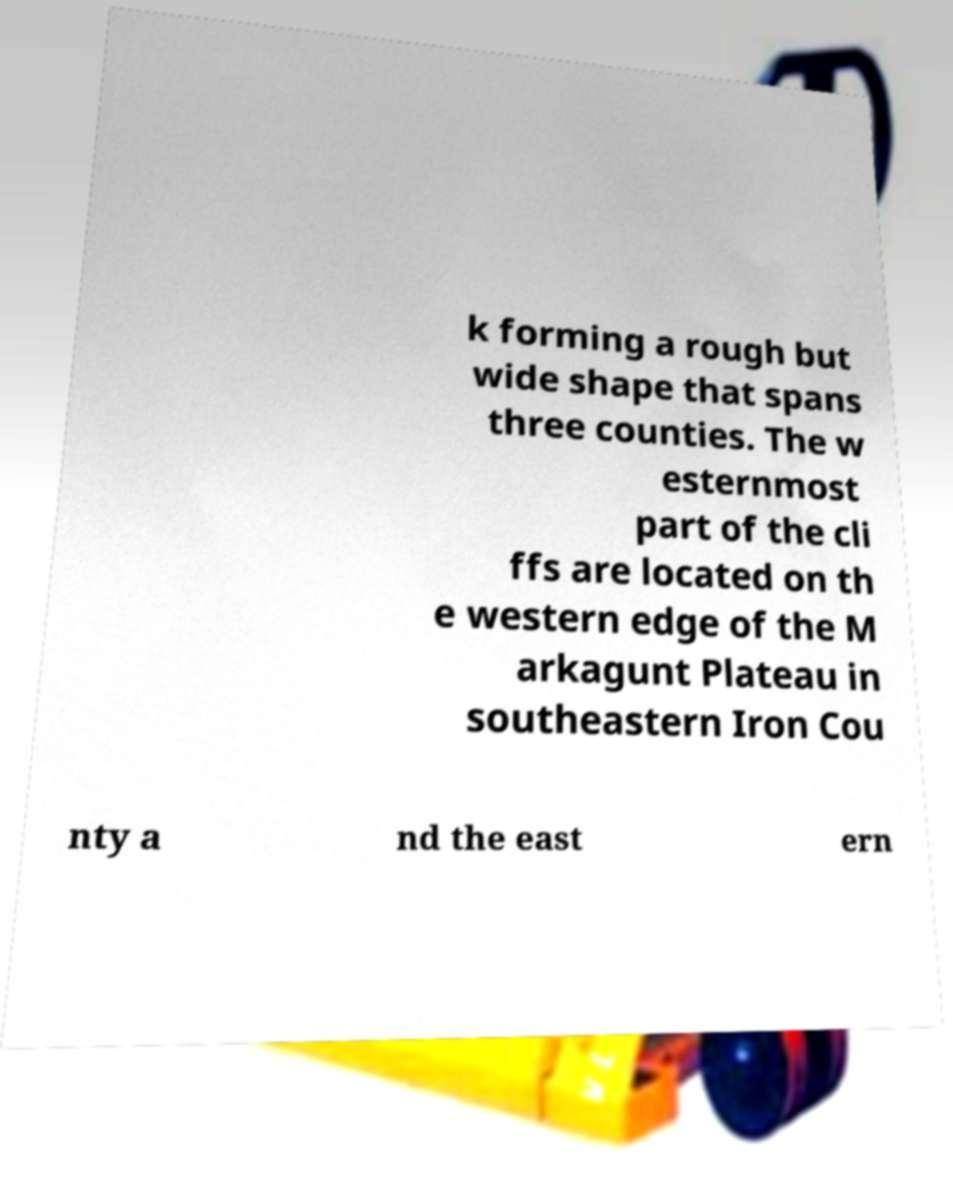Could you extract and type out the text from this image? k forming a rough but wide shape that spans three counties. The w esternmost part of the cli ffs are located on th e western edge of the M arkagunt Plateau in southeastern Iron Cou nty a nd the east ern 